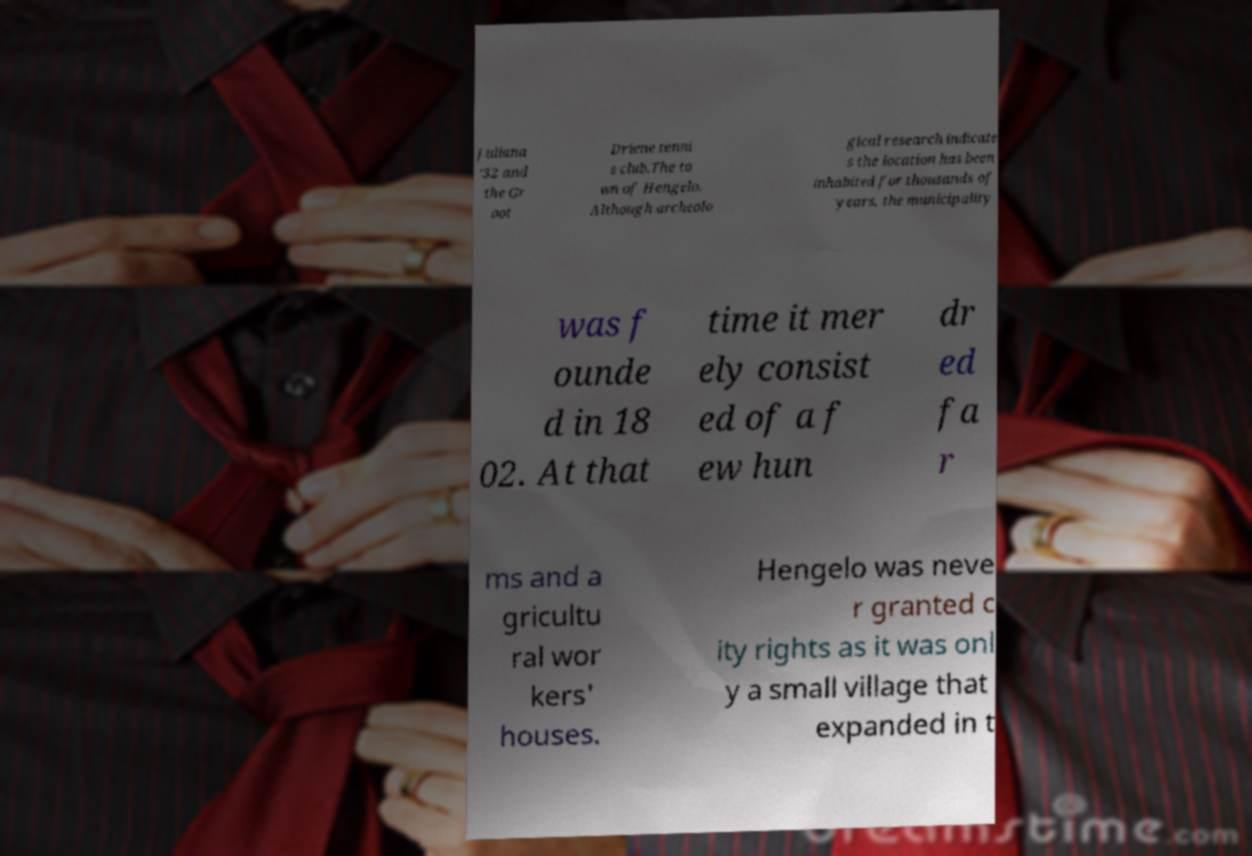Please read and relay the text visible in this image. What does it say? Juliana '32 and the Gr oot Driene tenni s club.The to wn of Hengelo. Although archeolo gical research indicate s the location has been inhabited for thousands of years, the municipality was f ounde d in 18 02. At that time it mer ely consist ed of a f ew hun dr ed fa r ms and a gricultu ral wor kers' houses. Hengelo was neve r granted c ity rights as it was onl y a small village that expanded in t 